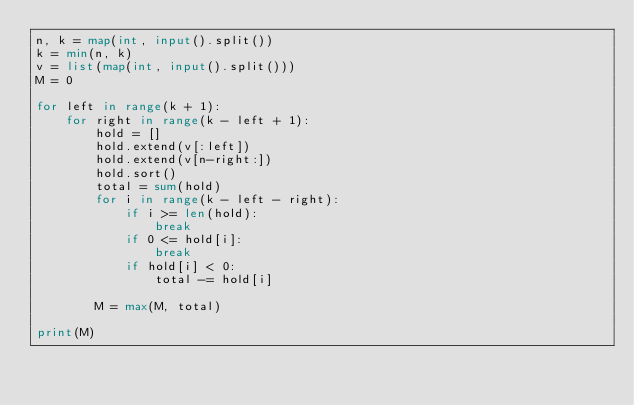Convert code to text. <code><loc_0><loc_0><loc_500><loc_500><_Python_>n, k = map(int, input().split())
k = min(n, k)
v = list(map(int, input().split()))
M = 0

for left in range(k + 1):
    for right in range(k - left + 1):
        hold = []
        hold.extend(v[:left])
        hold.extend(v[n-right:])
        hold.sort()
        total = sum(hold)
        for i in range(k - left - right):
            if i >= len(hold):
                break
            if 0 <= hold[i]:
                break
            if hold[i] < 0:
                total -= hold[i]

        M = max(M, total)

print(M)

</code> 